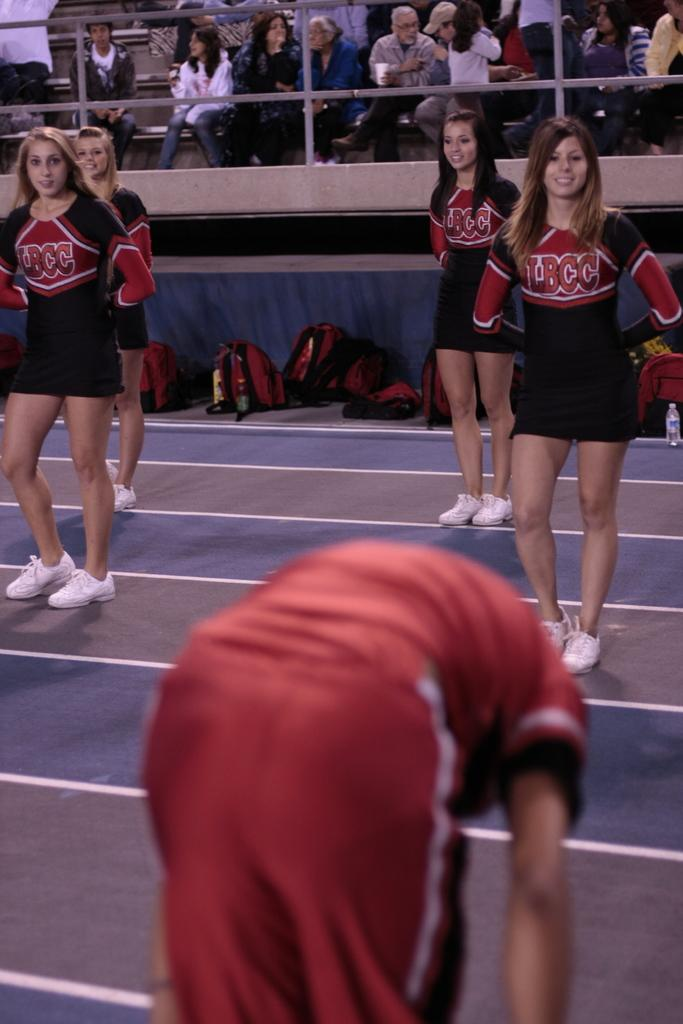<image>
Describe the image concisely. some cheerleaders with jerseys that say BCC on them 